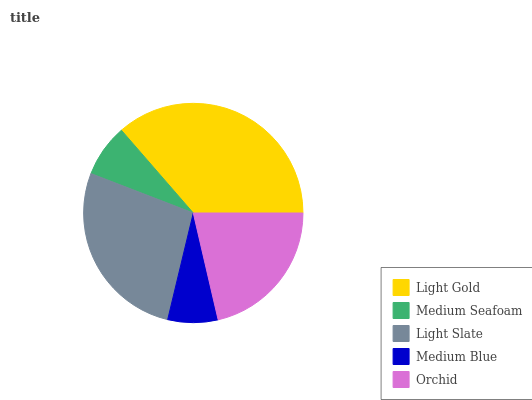Is Medium Blue the minimum?
Answer yes or no. Yes. Is Light Gold the maximum?
Answer yes or no. Yes. Is Medium Seafoam the minimum?
Answer yes or no. No. Is Medium Seafoam the maximum?
Answer yes or no. No. Is Light Gold greater than Medium Seafoam?
Answer yes or no. Yes. Is Medium Seafoam less than Light Gold?
Answer yes or no. Yes. Is Medium Seafoam greater than Light Gold?
Answer yes or no. No. Is Light Gold less than Medium Seafoam?
Answer yes or no. No. Is Orchid the high median?
Answer yes or no. Yes. Is Orchid the low median?
Answer yes or no. Yes. Is Medium Seafoam the high median?
Answer yes or no. No. Is Light Gold the low median?
Answer yes or no. No. 